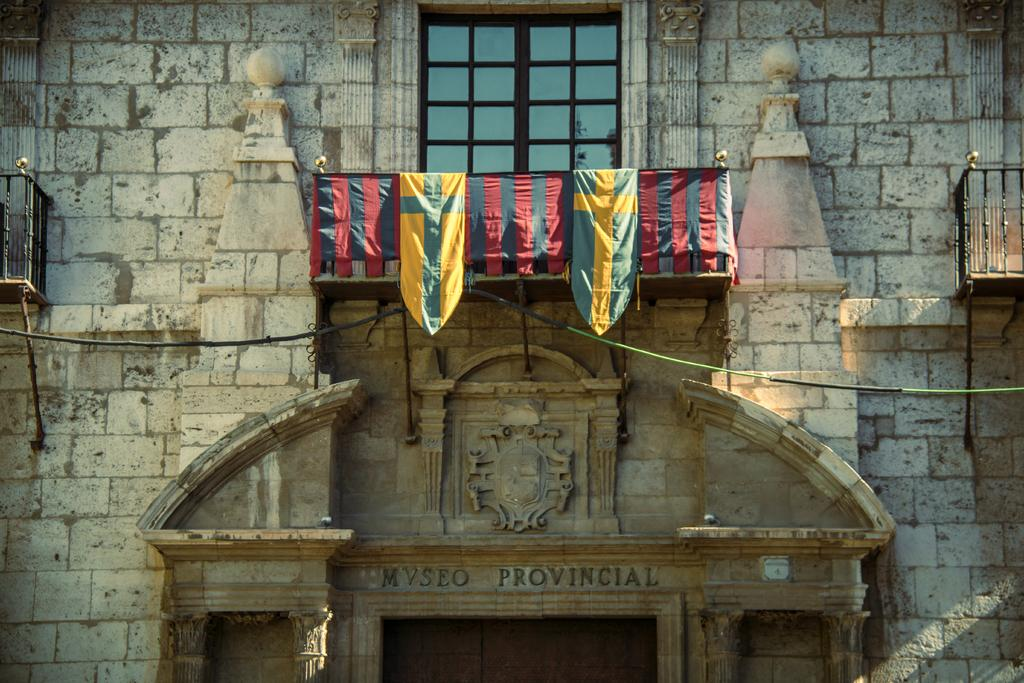What can be seen through the window in the image? The facts provided do not specify what can be seen through the window. How many flags are visible in the image? There are flags in the image, but the exact number is not specified. What type of fences are present in the image? The facts provided do not specify the type of fences in the image. What is the rope used for in the image? The facts provided do not specify the purpose of the rope in the image. What is the design of in the image? The facts provided do not specify the design in the image. What does the text on the wall say in the image? The facts provided do not specify the text on the wall in the image. What are the objects in the image? The facts provided do not specify the objects in the image. What color is the silver card blowing in the wind in the image? There is no silver card blowing in the wind in the image. 